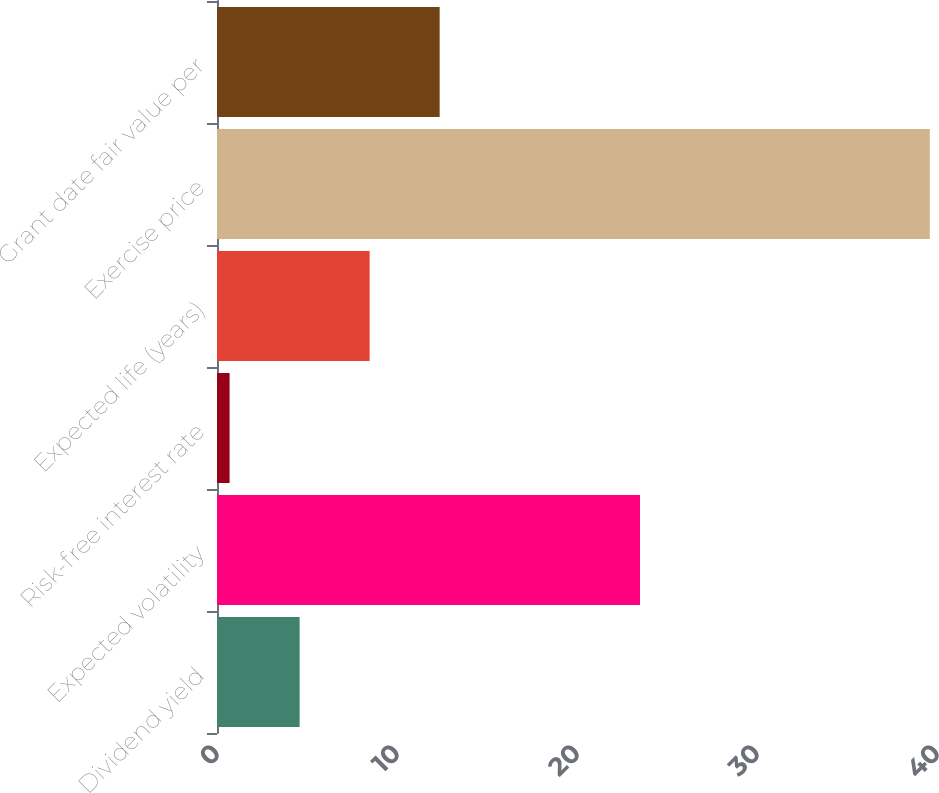Convert chart. <chart><loc_0><loc_0><loc_500><loc_500><bar_chart><fcel>Dividend yield<fcel>Expected volatility<fcel>Risk-free interest rate<fcel>Expected life (years)<fcel>Exercise price<fcel>Grant date fair value per<nl><fcel>4.59<fcel>23.5<fcel>0.7<fcel>8.48<fcel>39.6<fcel>12.37<nl></chart> 